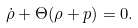Convert formula to latex. <formula><loc_0><loc_0><loc_500><loc_500>\dot { \rho } + \Theta ( \rho + p ) = 0 .</formula> 